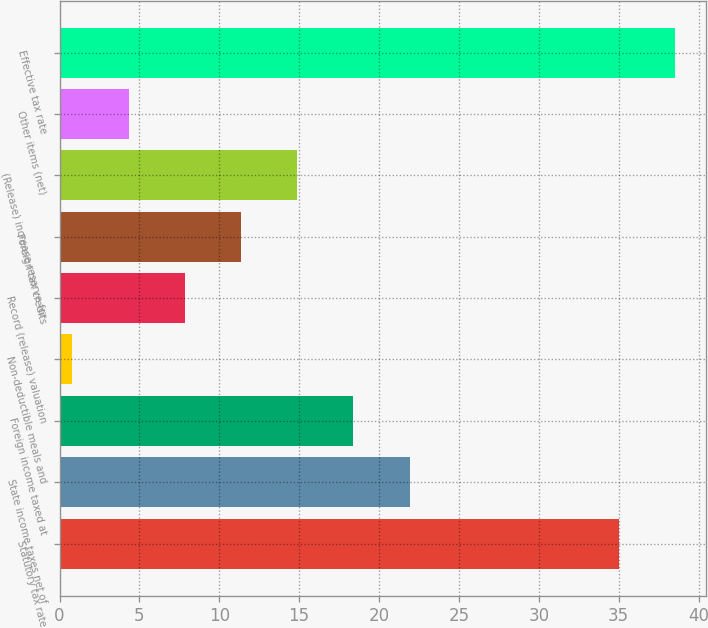Convert chart. <chart><loc_0><loc_0><loc_500><loc_500><bar_chart><fcel>Statutory tax rate<fcel>State income taxes net of<fcel>Foreign income taxed at<fcel>Non-deductible meals and<fcel>Record (release) valuation<fcel>Foreign tax credits<fcel>(Release) increase reserve for<fcel>Other items (net)<fcel>Effective tax rate<nl><fcel>35<fcel>21.92<fcel>18.4<fcel>0.8<fcel>7.84<fcel>11.36<fcel>14.88<fcel>4.32<fcel>38.52<nl></chart> 